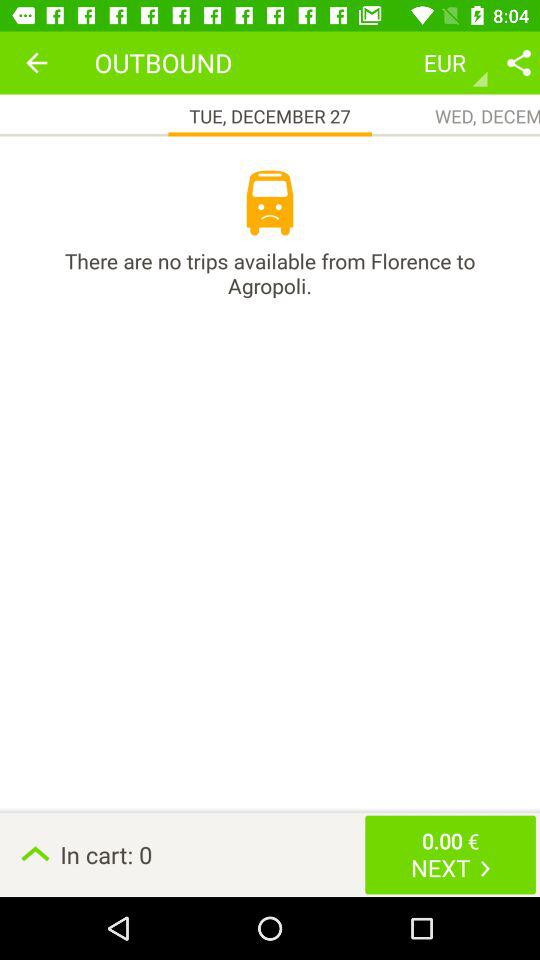What is the number of items in the cart? There are 0 items in the cart. 